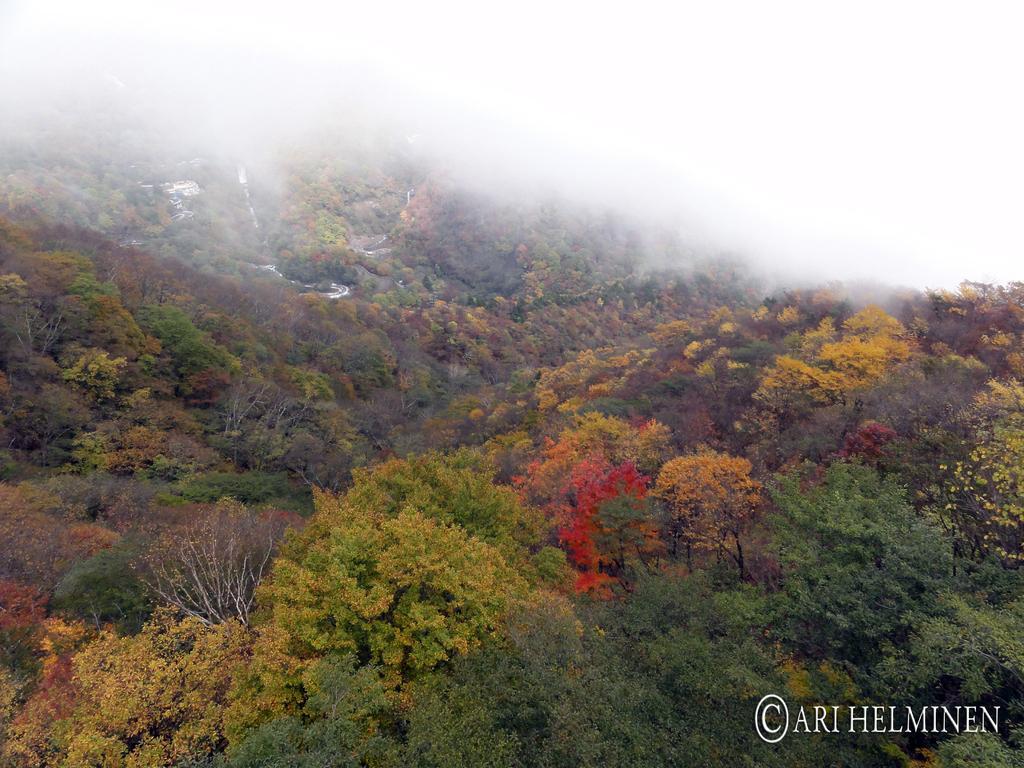Could you give a brief overview of what you see in this image? In this picture we can see trees and at the bottom right corner of an image we can see a watermark. 